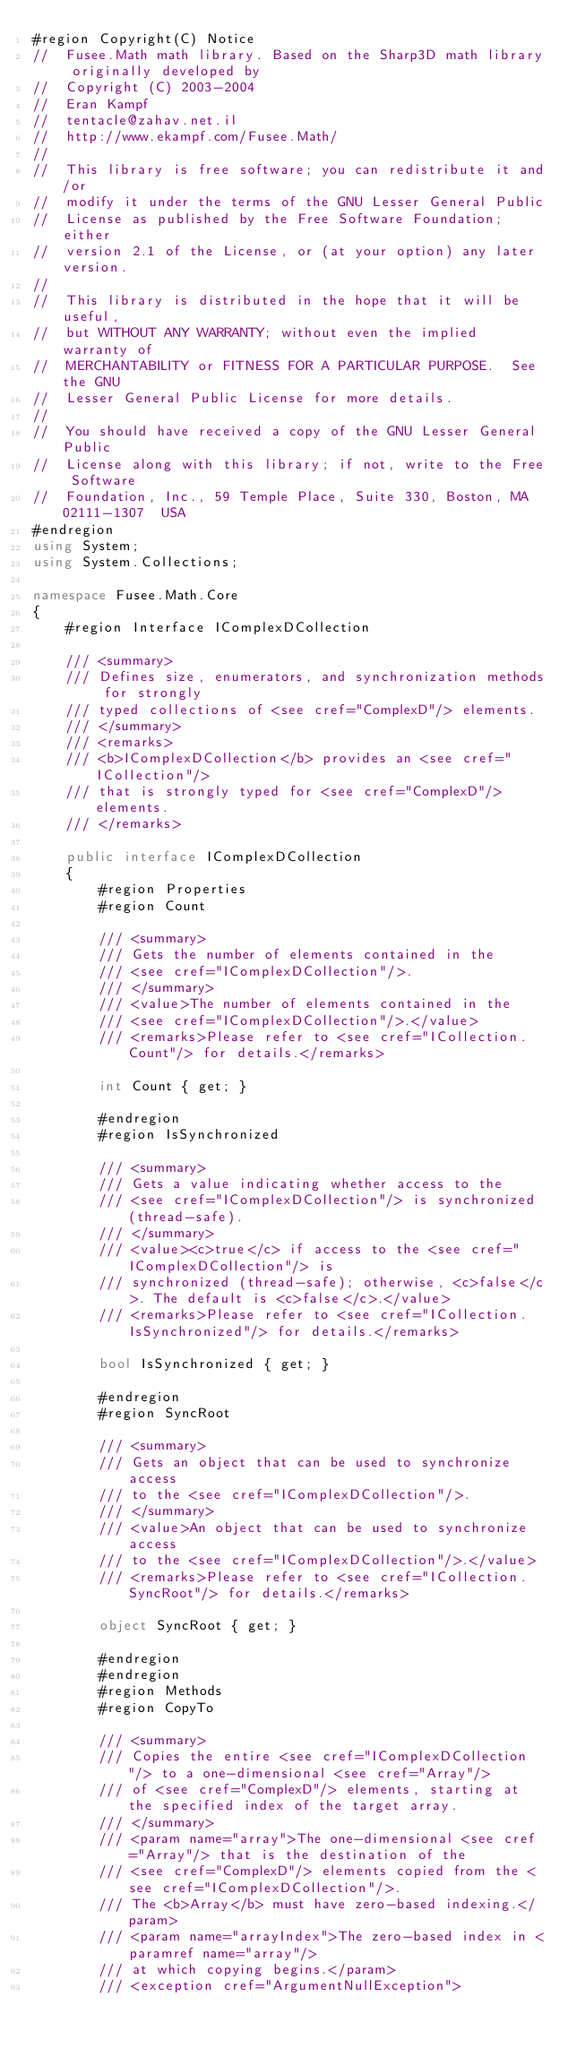Convert code to text. <code><loc_0><loc_0><loc_500><loc_500><_C#_>#region Copyright(C) Notice
//	Fusee.Math math library. Based on the Sharp3D math library originally developed by
//	Copyright (C) 2003-2004  
//	Eran Kampf
//	tentacle@zahav.net.il
//	http://www.ekampf.com/Fusee.Math/
//
//	This library is free software; you can redistribute it and/or
//	modify it under the terms of the GNU Lesser General Public
//	License as published by the Free Software Foundation; either
//	version 2.1 of the License, or (at your option) any later version.
//
//	This library is distributed in the hope that it will be useful,
//	but WITHOUT ANY WARRANTY; without even the implied warranty of
//	MERCHANTABILITY or FITNESS FOR A PARTICULAR PURPOSE.  See the GNU
//	Lesser General Public License for more details.
//
//	You should have received a copy of the GNU Lesser General Public
//	License along with this library; if not, write to the Free Software
//	Foundation, Inc., 59 Temple Place, Suite 330, Boston, MA  02111-1307  USA
#endregion
using System;
using System.Collections;

namespace Fusee.Math.Core 
{
	#region Interface IComplexDCollection

	/// <summary>
	/// Defines size, enumerators, and synchronization methods for strongly
	/// typed collections of <see cref="ComplexD"/> elements.
	/// </summary>
	/// <remarks>
	/// <b>IComplexDCollection</b> provides an <see cref="ICollection"/>
	/// that is strongly typed for <see cref="ComplexD"/> elements.
	/// </remarks>

	public interface IComplexDCollection 
	{
		#region Properties
		#region Count

		/// <summary>
		/// Gets the number of elements contained in the
		/// <see cref="IComplexDCollection"/>.
		/// </summary>
		/// <value>The number of elements contained in the
		/// <see cref="IComplexDCollection"/>.</value>
		/// <remarks>Please refer to <see cref="ICollection.Count"/> for details.</remarks>

		int Count { get; }

		#endregion
		#region IsSynchronized

		/// <summary>
		/// Gets a value indicating whether access to the
		/// <see cref="IComplexDCollection"/> is synchronized (thread-safe).
		/// </summary>
		/// <value><c>true</c> if access to the <see cref="IComplexDCollection"/> is
		/// synchronized (thread-safe); otherwise, <c>false</c>. The default is <c>false</c>.</value>
		/// <remarks>Please refer to <see cref="ICollection.IsSynchronized"/> for details.</remarks>

		bool IsSynchronized { get; }

		#endregion
		#region SyncRoot

		/// <summary>
		/// Gets an object that can be used to synchronize access
		/// to the <see cref="IComplexDCollection"/>.
		/// </summary>
		/// <value>An object that can be used to synchronize access
		/// to the <see cref="IComplexDCollection"/>.</value>
		/// <remarks>Please refer to <see cref="ICollection.SyncRoot"/> for details.</remarks>

		object SyncRoot { get; }

		#endregion
		#endregion
		#region Methods
		#region CopyTo

		/// <summary>
		/// Copies the entire <see cref="IComplexDCollection"/> to a one-dimensional <see cref="Array"/>
		/// of <see cref="ComplexD"/> elements, starting at the specified index of the target array.
		/// </summary>
		/// <param name="array">The one-dimensional <see cref="Array"/> that is the destination of the
		/// <see cref="ComplexD"/> elements copied from the <see cref="IComplexDCollection"/>.
		/// The <b>Array</b> must have zero-based indexing.</param>
		/// <param name="arrayIndex">The zero-based index in <paramref name="array"/>
		/// at which copying begins.</param>
		/// <exception cref="ArgumentNullException"></code> 